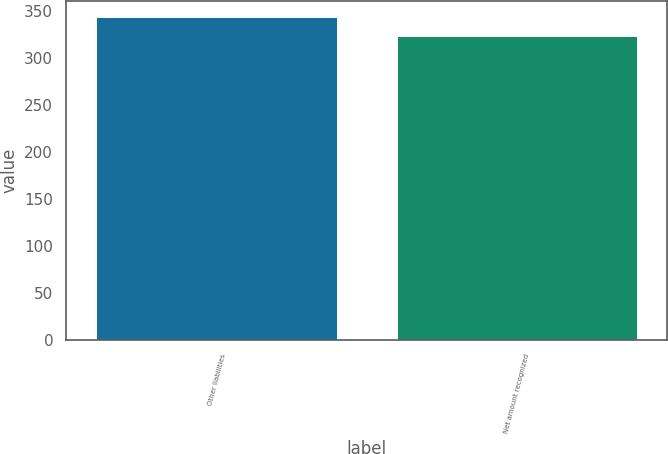Convert chart to OTSL. <chart><loc_0><loc_0><loc_500><loc_500><bar_chart><fcel>Other liabilities<fcel>Net amount recognized<nl><fcel>344<fcel>323.3<nl></chart> 